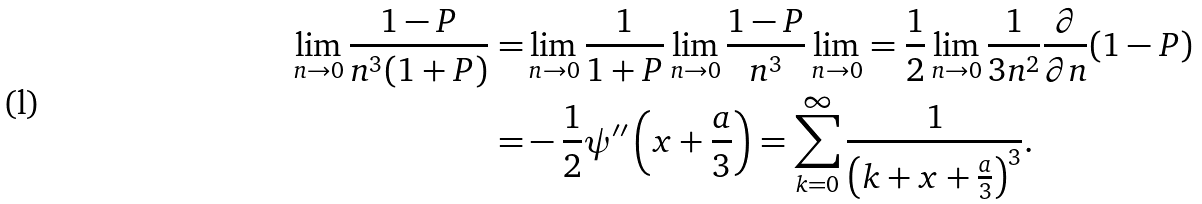Convert formula to latex. <formula><loc_0><loc_0><loc_500><loc_500>\lim _ { n \rightarrow 0 } \frac { 1 - P } { n ^ { 3 } ( 1 + P ) } = & \lim _ { n \rightarrow 0 } \frac { 1 } { 1 + P } \lim _ { n \rightarrow 0 } \frac { 1 - P } { n ^ { 3 } } \lim _ { n \rightarrow 0 } = \frac { 1 } { 2 } \lim _ { n \rightarrow 0 } \frac { 1 } { 3 n ^ { 2 } } \frac { \partial } { \partial n } ( 1 - P ) \\ = & - \frac { 1 } { 2 } \psi ^ { \prime \prime } \left ( x + \frac { a } { 3 } \right ) = \sum _ { k = 0 } ^ { \infty } \frac { 1 } { \left ( k + x + \frac { a } { 3 } \right ) ^ { 3 } } .</formula> 